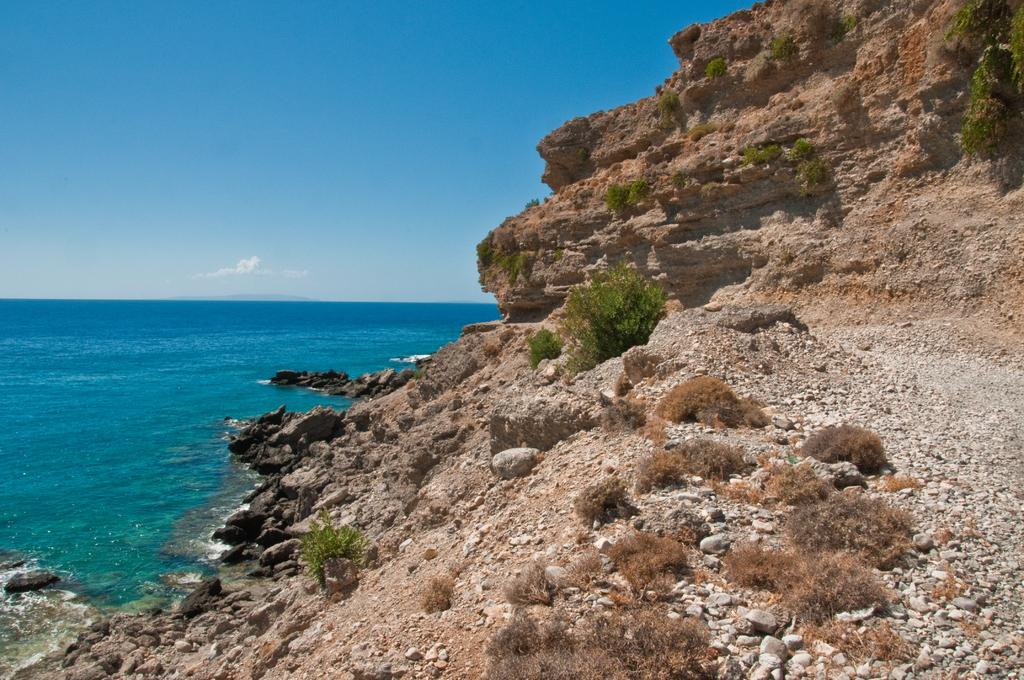What type of natural feature is the main subject of the image? There is an ocean in the image. What other geographical feature can be seen on the right side of the image? There is a mountain on the right side of the image. What type of vegetation is near the mountain? There is grass near the mountain. What can be found at the bottom of the image? Small stones are visible at the bottom of the image. What is visible at the top of the image? The sky is visible at the top of the image. What can be observed in the sky? Clouds are present in the sky. How many snakes are slithering through the grass in the image? There are no snakes present in the image; it features an ocean, a mountain, grass, small stones, and a sky with clouds. What type of ray is swimming in the ocean in the image? There are no rays present in the image; it features an ocean, a mountain, grass, small stones, and a sky with clouds. 